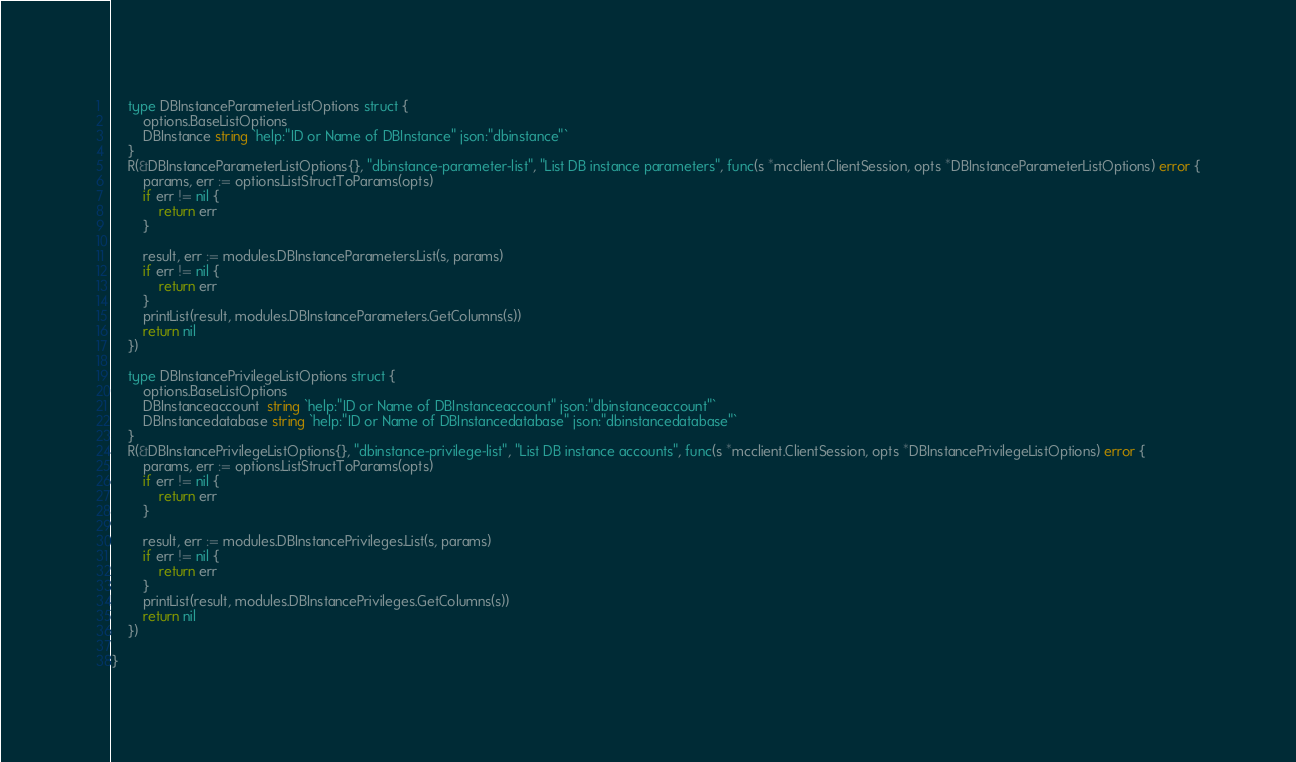Convert code to text. <code><loc_0><loc_0><loc_500><loc_500><_Go_>
	type DBInstanceParameterListOptions struct {
		options.BaseListOptions
		DBInstance string `help:"ID or Name of DBInstance" json:"dbinstance"`
	}
	R(&DBInstanceParameterListOptions{}, "dbinstance-parameter-list", "List DB instance parameters", func(s *mcclient.ClientSession, opts *DBInstanceParameterListOptions) error {
		params, err := options.ListStructToParams(opts)
		if err != nil {
			return err
		}

		result, err := modules.DBInstanceParameters.List(s, params)
		if err != nil {
			return err
		}
		printList(result, modules.DBInstanceParameters.GetColumns(s))
		return nil
	})

	type DBInstancePrivilegeListOptions struct {
		options.BaseListOptions
		DBInstanceaccount  string `help:"ID or Name of DBInstanceaccount" json:"dbinstanceaccount"`
		DBInstancedatabase string `help:"ID or Name of DBInstancedatabase" json:"dbinstancedatabase"`
	}
	R(&DBInstancePrivilegeListOptions{}, "dbinstance-privilege-list", "List DB instance accounts", func(s *mcclient.ClientSession, opts *DBInstancePrivilegeListOptions) error {
		params, err := options.ListStructToParams(opts)
		if err != nil {
			return err
		}

		result, err := modules.DBInstancePrivileges.List(s, params)
		if err != nil {
			return err
		}
		printList(result, modules.DBInstancePrivileges.GetColumns(s))
		return nil
	})

}
</code> 